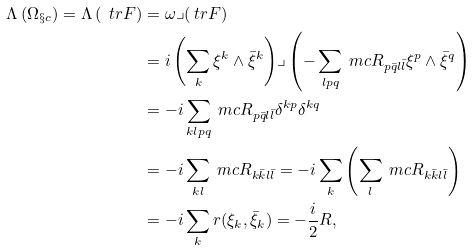Convert formula to latex. <formula><loc_0><loc_0><loc_500><loc_500>\Lambda \left ( \Omega _ { \S c } \right ) = \Lambda \left ( \ t r F \right ) & = \omega \lrcorner ( \ t r F ) \\ & = i \left ( \sum _ { k } \xi ^ { k } \wedge \bar { \xi } ^ { k } \right ) \lrcorner \left ( - \sum _ { l p q } \ m c { R } _ { p \bar { q } l \bar { l } } \xi ^ { p } \wedge \bar { \xi } ^ { q } \right ) \\ & = - i \sum _ { k l p q } \ m c { R } _ { p \bar { q } l \bar { l } } \delta ^ { k p } \delta ^ { k q } \\ & = - i \sum _ { k l } \ m c { R } _ { k \bar { k } l \bar { l } } = - i \sum _ { k } \left ( \sum _ { l } \ m c { R } _ { k \bar { k } l \bar { l } } \right ) \\ & = - i \sum _ { k } r ( \xi _ { k } , \bar { \xi } _ { k } ) = - \frac { i } { 2 } R ,</formula> 